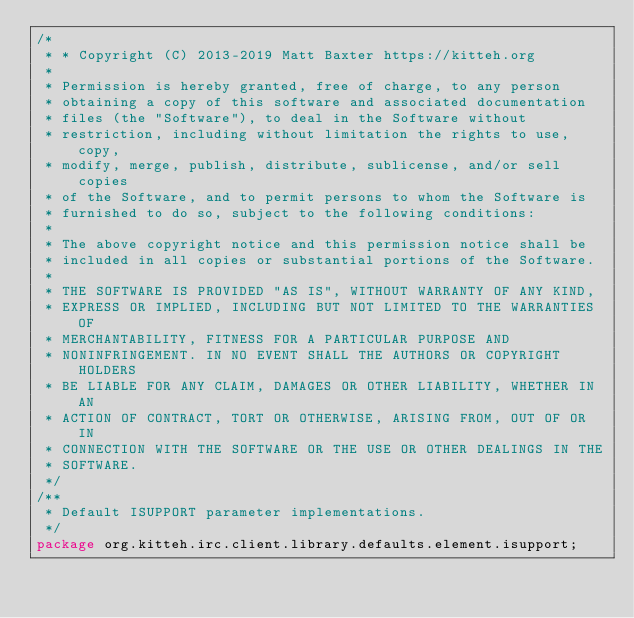Convert code to text. <code><loc_0><loc_0><loc_500><loc_500><_Java_>/*
 * * Copyright (C) 2013-2019 Matt Baxter https://kitteh.org
 *
 * Permission is hereby granted, free of charge, to any person
 * obtaining a copy of this software and associated documentation
 * files (the "Software"), to deal in the Software without
 * restriction, including without limitation the rights to use, copy,
 * modify, merge, publish, distribute, sublicense, and/or sell copies
 * of the Software, and to permit persons to whom the Software is
 * furnished to do so, subject to the following conditions:
 *
 * The above copyright notice and this permission notice shall be
 * included in all copies or substantial portions of the Software.
 *
 * THE SOFTWARE IS PROVIDED "AS IS", WITHOUT WARRANTY OF ANY KIND,
 * EXPRESS OR IMPLIED, INCLUDING BUT NOT LIMITED TO THE WARRANTIES OF
 * MERCHANTABILITY, FITNESS FOR A PARTICULAR PURPOSE AND
 * NONINFRINGEMENT. IN NO EVENT SHALL THE AUTHORS OR COPYRIGHT HOLDERS
 * BE LIABLE FOR ANY CLAIM, DAMAGES OR OTHER LIABILITY, WHETHER IN AN
 * ACTION OF CONTRACT, TORT OR OTHERWISE, ARISING FROM, OUT OF OR IN
 * CONNECTION WITH THE SOFTWARE OR THE USE OR OTHER DEALINGS IN THE
 * SOFTWARE.
 */
/**
 * Default ISUPPORT parameter implementations.
 */
package org.kitteh.irc.client.library.defaults.element.isupport;
</code> 